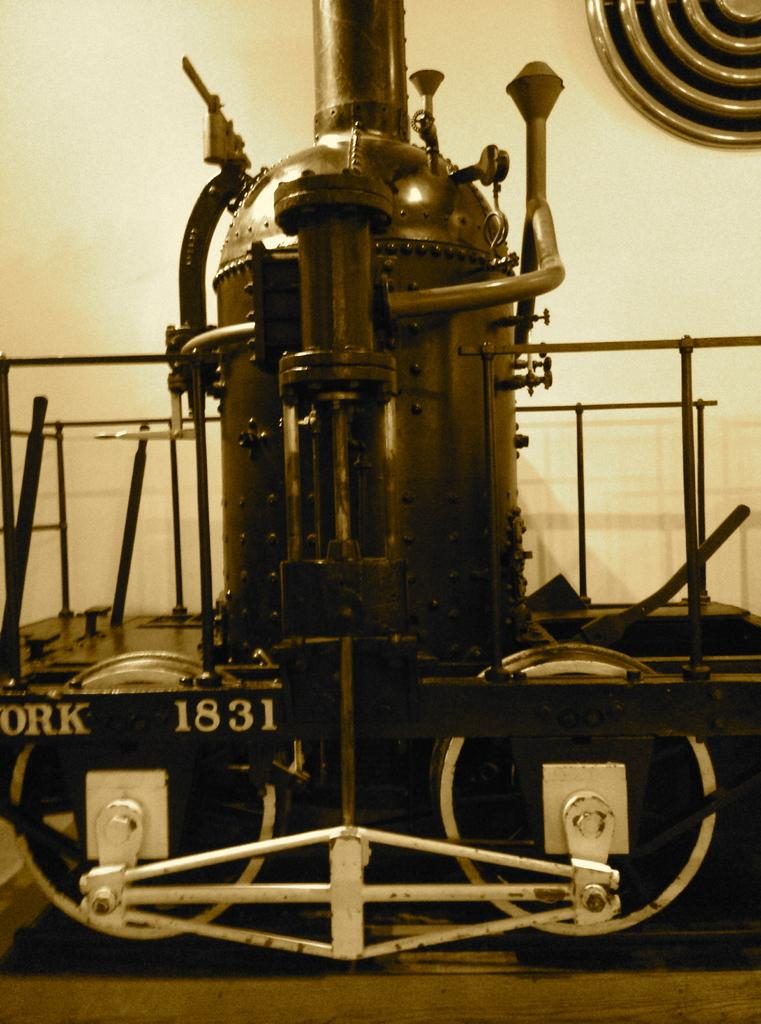What is the main object in the image? There is a machine in the image. What material are the poles on the machine made of? The machine has metal poles. How is the machine positioned in the image? The machine has wheels, which suggests it is mobile. What is the machine placed on in the image? The machine is placed on a surface. What can be seen in the background of the image? There is a wall visible in the image. What is the profit margin of the machine in the image? There is no information about the profit margin of the machine in the image, as it does not provide any financial details. 